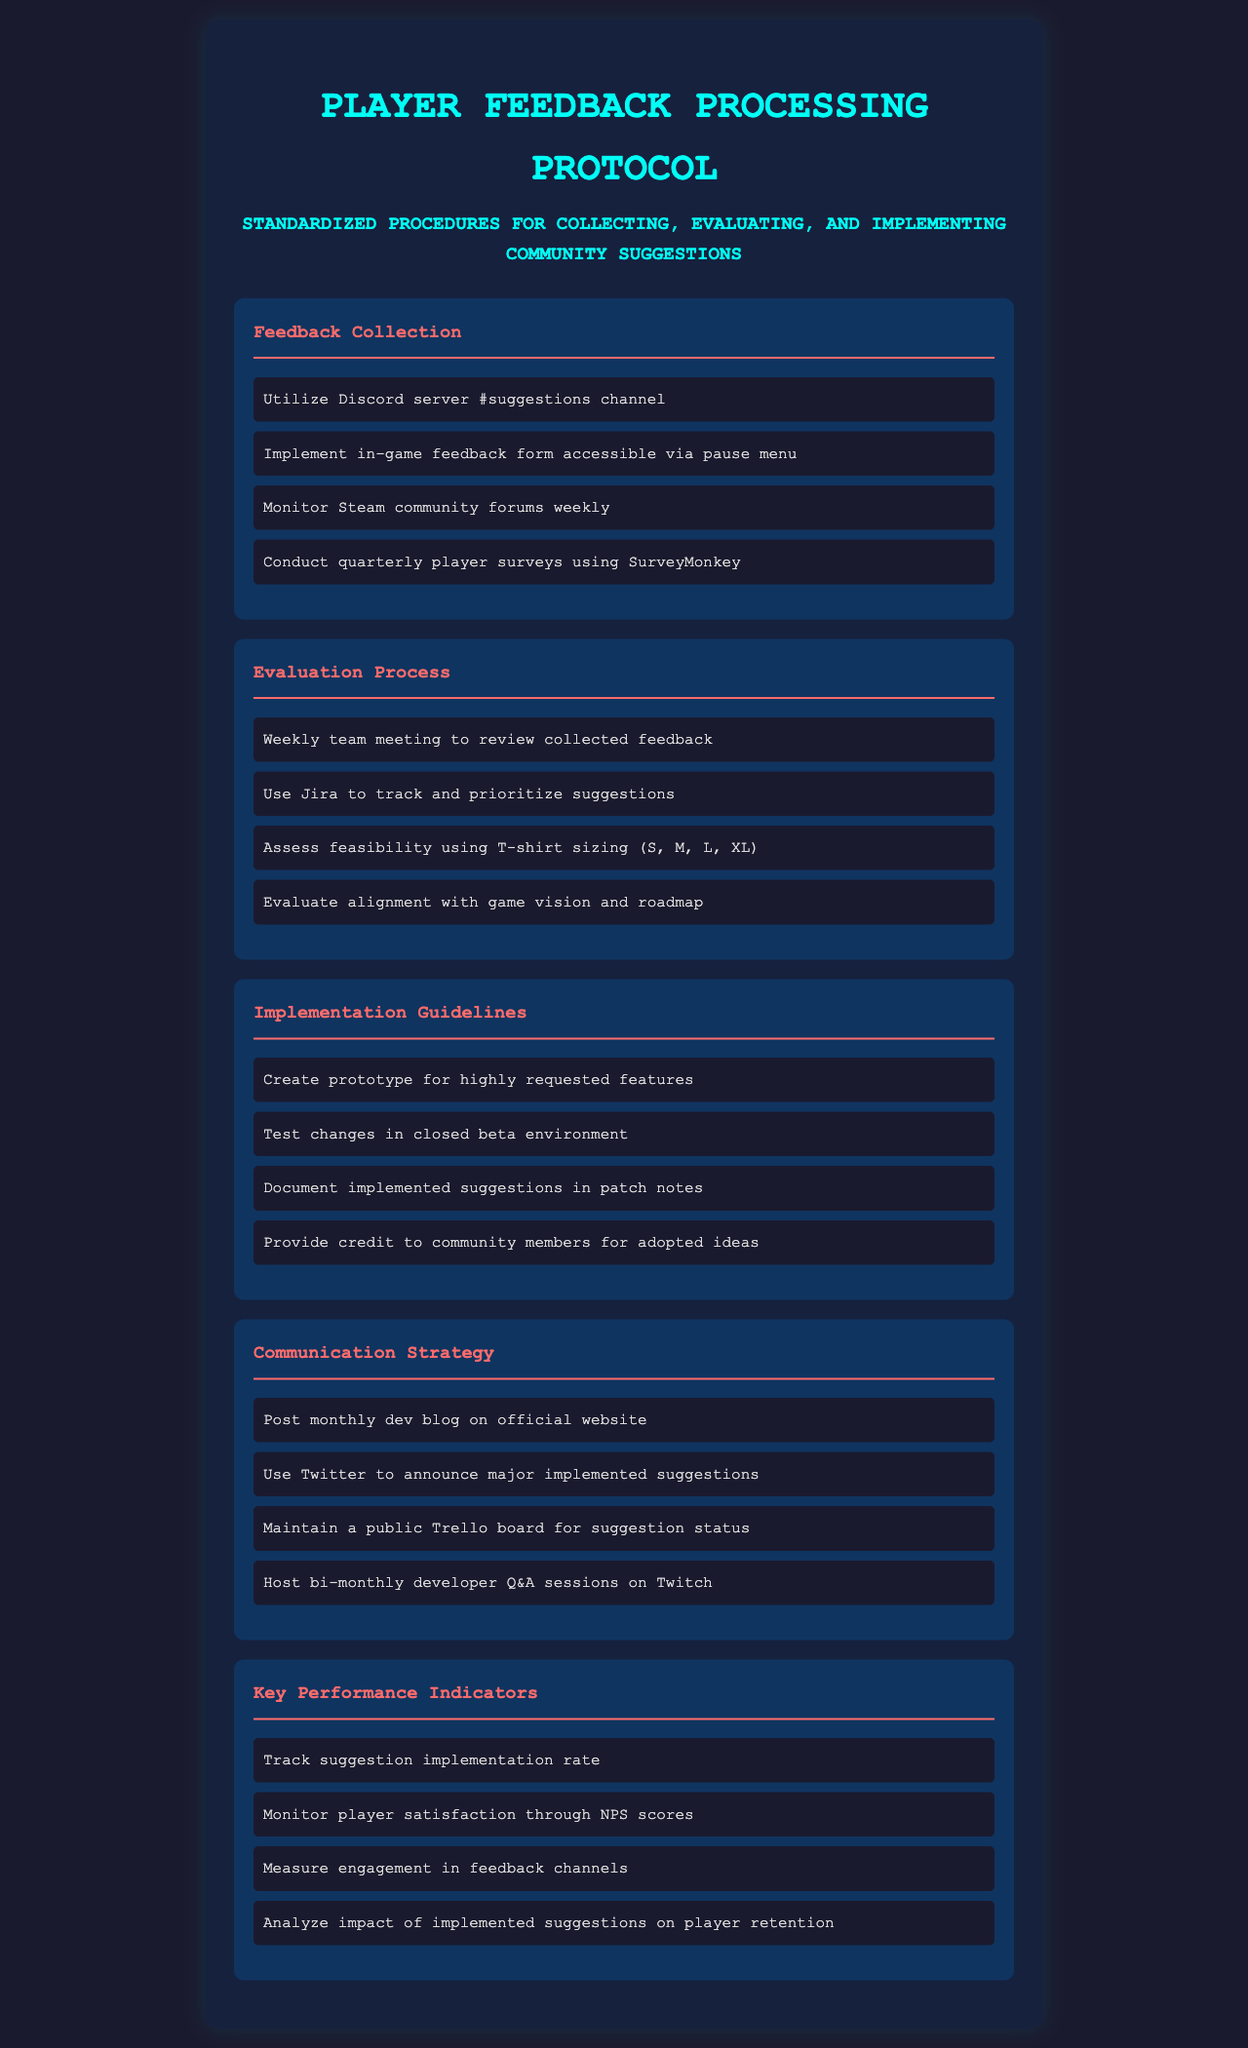What is the purpose of the document? The document outlines standardized procedures for collecting, evaluating, and implementing community suggestions related to player feedback.
Answer: Standardized procedures for collecting, evaluating, and implementing community suggestions How often are player surveys conducted? The document states that player surveys are conducted quarterly, providing a specific timeframe for these activities.
Answer: Quarterly What tool is used to track and prioritize suggestions? The evaluation process mentions using Jira as a tool for tracking and prioritizing the community suggestions.
Answer: Jira How frequently do team meetings to review feedback occur? The document specifies that weekly team meetings are held to review the collected feedback, indicating a regular schedule.
Answer: Weekly What is a key performance indicator for monitoring player satisfaction? The document highlights that NPS scores are used to measure player satisfaction, showcasing a specific metric for evaluation.
Answer: NPS scores What type of environment is used to test changes before implementation? The implementation guidelines specify that changes are tested in a closed beta environment prior to broader rollout.
Answer: Closed beta environment What platform is mentioned for hosting developer Q&A sessions? The communication strategy includes hosting Q&A sessions on Twitch, identifying the specific platform for this interaction.
Answer: Twitch What should be documented in patch notes? The implementation guidelines state that implemented suggestions should be documented in patch notes, indicating what information should be included in updates.
Answer: Implemented suggestions What color is used for section headings? The document notes that section headings are colored with a specific shade (indicating a visual seen in the document), which helps in organizing content visually.
Answer: #ff6b6b 